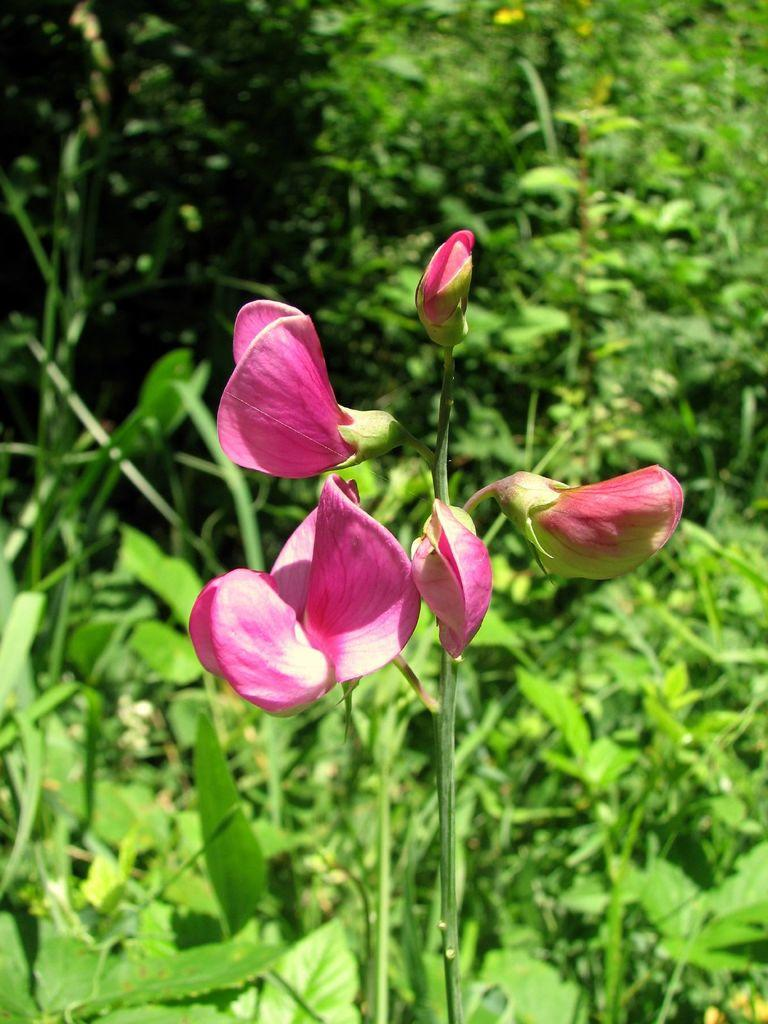What type of plant is present in the image? There are flowers on a plant in the image. What color are the flowers on the plant? The flowers are pink. What else can be seen in the background of the image? There are plants with leaves in the background of the image. Can you tell me how many insects are guiding the skate in the image? There are no insects or skates present in the image; it features a plant with pink flowers and other plants with leaves in the background. 